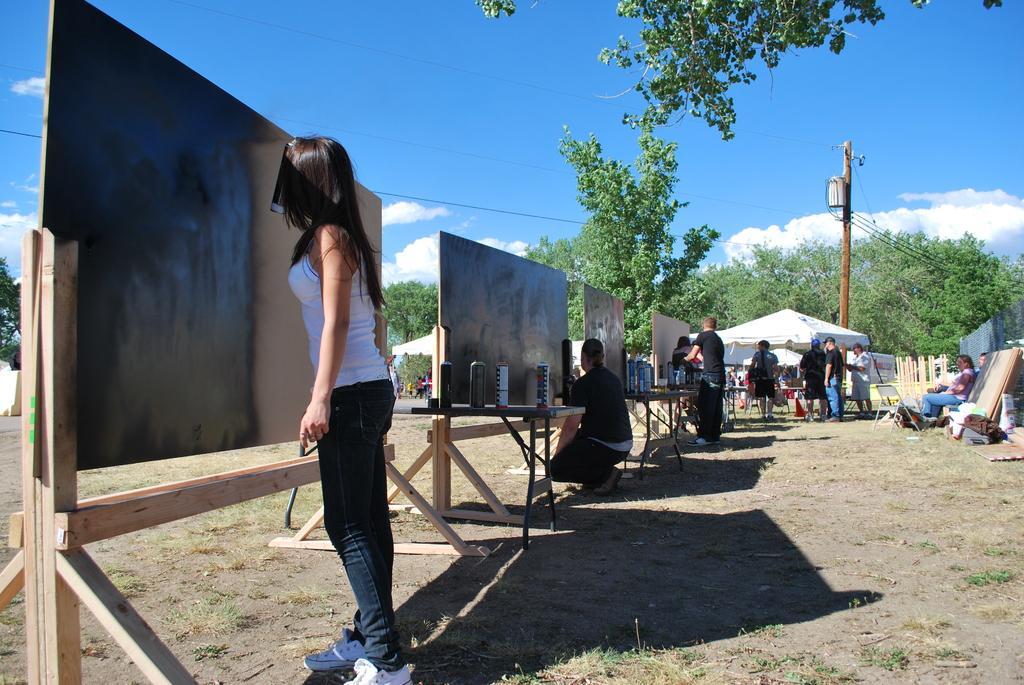How would you summarize this image in a sentence or two? In this image, we can see people and some of them are wearing caps and holding an object's. In the background, we can see boards and some objects on the tables, tents, chairs, a fence, trees and we can see a pole along with wires and we can see some vehicles and traffic cone. On the right, we can see some people sitting. At the bottom, there is ground and at the top, there is sky. 